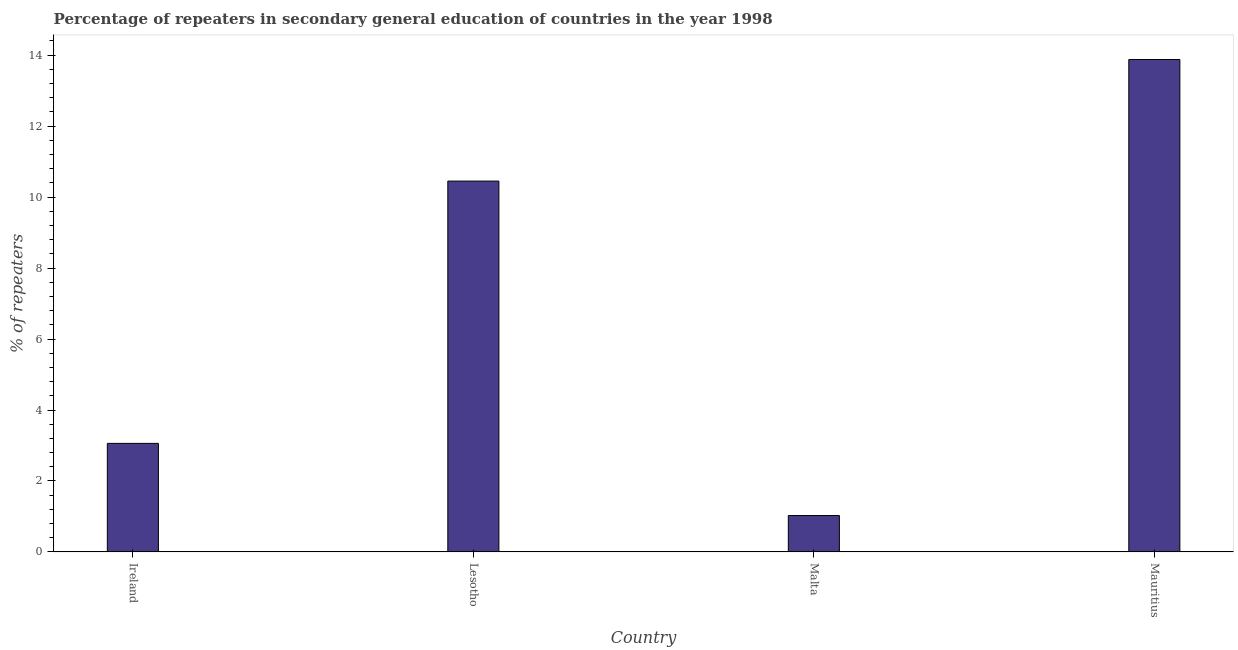Does the graph contain any zero values?
Ensure brevity in your answer.  No. Does the graph contain grids?
Provide a short and direct response. No. What is the title of the graph?
Provide a short and direct response. Percentage of repeaters in secondary general education of countries in the year 1998. What is the label or title of the X-axis?
Your answer should be very brief. Country. What is the label or title of the Y-axis?
Make the answer very short. % of repeaters. What is the percentage of repeaters in Ireland?
Offer a terse response. 3.06. Across all countries, what is the maximum percentage of repeaters?
Ensure brevity in your answer.  13.88. Across all countries, what is the minimum percentage of repeaters?
Your answer should be very brief. 1.03. In which country was the percentage of repeaters maximum?
Keep it short and to the point. Mauritius. In which country was the percentage of repeaters minimum?
Keep it short and to the point. Malta. What is the sum of the percentage of repeaters?
Your answer should be very brief. 28.41. What is the difference between the percentage of repeaters in Lesotho and Mauritius?
Ensure brevity in your answer.  -3.43. What is the average percentage of repeaters per country?
Your answer should be very brief. 7.1. What is the median percentage of repeaters?
Your response must be concise. 6.76. In how many countries, is the percentage of repeaters greater than 1.2 %?
Ensure brevity in your answer.  3. What is the ratio of the percentage of repeaters in Ireland to that in Mauritius?
Provide a succinct answer. 0.22. Is the difference between the percentage of repeaters in Lesotho and Mauritius greater than the difference between any two countries?
Your answer should be very brief. No. What is the difference between the highest and the second highest percentage of repeaters?
Offer a terse response. 3.43. What is the difference between the highest and the lowest percentage of repeaters?
Make the answer very short. 12.85. In how many countries, is the percentage of repeaters greater than the average percentage of repeaters taken over all countries?
Offer a terse response. 2. How many bars are there?
Your answer should be compact. 4. Are all the bars in the graph horizontal?
Keep it short and to the point. No. How many countries are there in the graph?
Ensure brevity in your answer.  4. What is the % of repeaters of Ireland?
Offer a very short reply. 3.06. What is the % of repeaters in Lesotho?
Your answer should be compact. 10.45. What is the % of repeaters in Malta?
Provide a succinct answer. 1.03. What is the % of repeaters in Mauritius?
Offer a very short reply. 13.88. What is the difference between the % of repeaters in Ireland and Lesotho?
Ensure brevity in your answer.  -7.39. What is the difference between the % of repeaters in Ireland and Malta?
Provide a short and direct response. 2.03. What is the difference between the % of repeaters in Ireland and Mauritius?
Your answer should be compact. -10.82. What is the difference between the % of repeaters in Lesotho and Malta?
Your answer should be compact. 9.43. What is the difference between the % of repeaters in Lesotho and Mauritius?
Make the answer very short. -3.43. What is the difference between the % of repeaters in Malta and Mauritius?
Provide a succinct answer. -12.85. What is the ratio of the % of repeaters in Ireland to that in Lesotho?
Keep it short and to the point. 0.29. What is the ratio of the % of repeaters in Ireland to that in Malta?
Your answer should be compact. 2.98. What is the ratio of the % of repeaters in Ireland to that in Mauritius?
Offer a very short reply. 0.22. What is the ratio of the % of repeaters in Lesotho to that in Malta?
Ensure brevity in your answer.  10.19. What is the ratio of the % of repeaters in Lesotho to that in Mauritius?
Your answer should be very brief. 0.75. What is the ratio of the % of repeaters in Malta to that in Mauritius?
Your answer should be very brief. 0.07. 